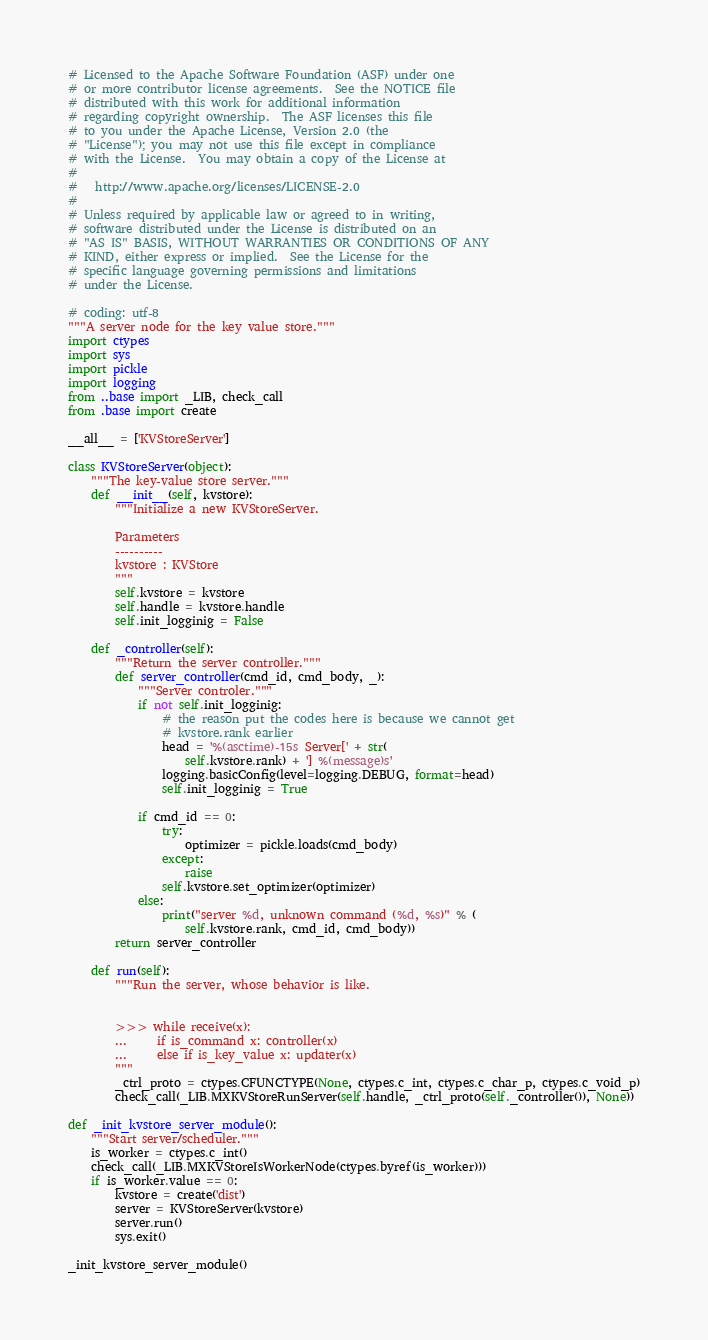Convert code to text. <code><loc_0><loc_0><loc_500><loc_500><_Python_># Licensed to the Apache Software Foundation (ASF) under one
# or more contributor license agreements.  See the NOTICE file
# distributed with this work for additional information
# regarding copyright ownership.  The ASF licenses this file
# to you under the Apache License, Version 2.0 (the
# "License"); you may not use this file except in compliance
# with the License.  You may obtain a copy of the License at
#
#   http://www.apache.org/licenses/LICENSE-2.0
#
# Unless required by applicable law or agreed to in writing,
# software distributed under the License is distributed on an
# "AS IS" BASIS, WITHOUT WARRANTIES OR CONDITIONS OF ANY
# KIND, either express or implied.  See the License for the
# specific language governing permissions and limitations
# under the License.

# coding: utf-8
"""A server node for the key value store."""
import ctypes
import sys
import pickle
import logging
from ..base import _LIB, check_call
from .base import create

__all__ = ['KVStoreServer']

class KVStoreServer(object):
    """The key-value store server."""
    def __init__(self, kvstore):
        """Initialize a new KVStoreServer.

        Parameters
        ----------
        kvstore : KVStore
        """
        self.kvstore = kvstore
        self.handle = kvstore.handle
        self.init_logginig = False

    def _controller(self):
        """Return the server controller."""
        def server_controller(cmd_id, cmd_body, _):
            """Server controler."""
            if not self.init_logginig:
                # the reason put the codes here is because we cannot get
                # kvstore.rank earlier
                head = '%(asctime)-15s Server[' + str(
                    self.kvstore.rank) + '] %(message)s'
                logging.basicConfig(level=logging.DEBUG, format=head)
                self.init_logginig = True

            if cmd_id == 0:
                try:
                    optimizer = pickle.loads(cmd_body)
                except:
                    raise
                self.kvstore.set_optimizer(optimizer)
            else:
                print("server %d, unknown command (%d, %s)" % (
                    self.kvstore.rank, cmd_id, cmd_body))
        return server_controller

    def run(self):
        """Run the server, whose behavior is like.


        >>> while receive(x):
        ...     if is_command x: controller(x)
        ...     else if is_key_value x: updater(x)
        """
        _ctrl_proto = ctypes.CFUNCTYPE(None, ctypes.c_int, ctypes.c_char_p, ctypes.c_void_p)
        check_call(_LIB.MXKVStoreRunServer(self.handle, _ctrl_proto(self._controller()), None))

def _init_kvstore_server_module():
    """Start server/scheduler."""
    is_worker = ctypes.c_int()
    check_call(_LIB.MXKVStoreIsWorkerNode(ctypes.byref(is_worker)))
    if is_worker.value == 0:
        kvstore = create('dist')
        server = KVStoreServer(kvstore)
        server.run()
        sys.exit()

_init_kvstore_server_module()
</code> 